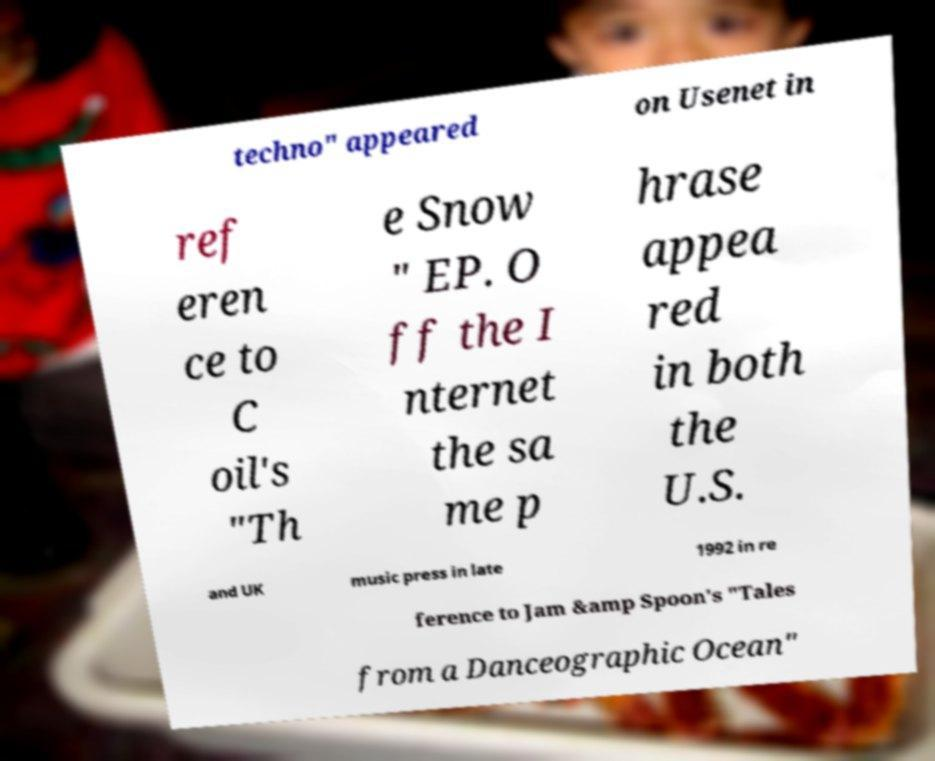Could you extract and type out the text from this image? techno" appeared on Usenet in ref eren ce to C oil's "Th e Snow " EP. O ff the I nternet the sa me p hrase appea red in both the U.S. and UK music press in late 1992 in re ference to Jam &amp Spoon's "Tales from a Danceographic Ocean" 